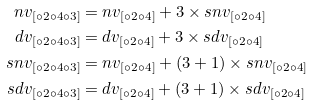<formula> <loc_0><loc_0><loc_500><loc_500>n v _ { [ \circ 2 \circ 4 \circ 3 ] } & = n v _ { [ \circ 2 \circ 4 ] } + 3 \times s n v _ { [ \circ 2 \circ 4 ] } \\ d v _ { [ \circ 2 \circ 4 \circ 3 ] } & = d v _ { [ \circ 2 \circ 4 ] } + 3 \times s d v _ { [ \circ 2 \circ 4 ] } \\ s n v _ { [ \circ 2 \circ 4 \circ 3 ] } & = n v _ { [ \circ 2 \circ 4 ] } + ( 3 + 1 ) \times s n v _ { [ \circ 2 \circ 4 ] } \\ s d v _ { [ \circ 2 \circ 4 \circ 3 ] } & = d v _ { [ \circ 2 \circ 4 ] } + ( 3 + 1 ) \times s d v _ { [ \circ 2 \circ 4 ] }</formula> 